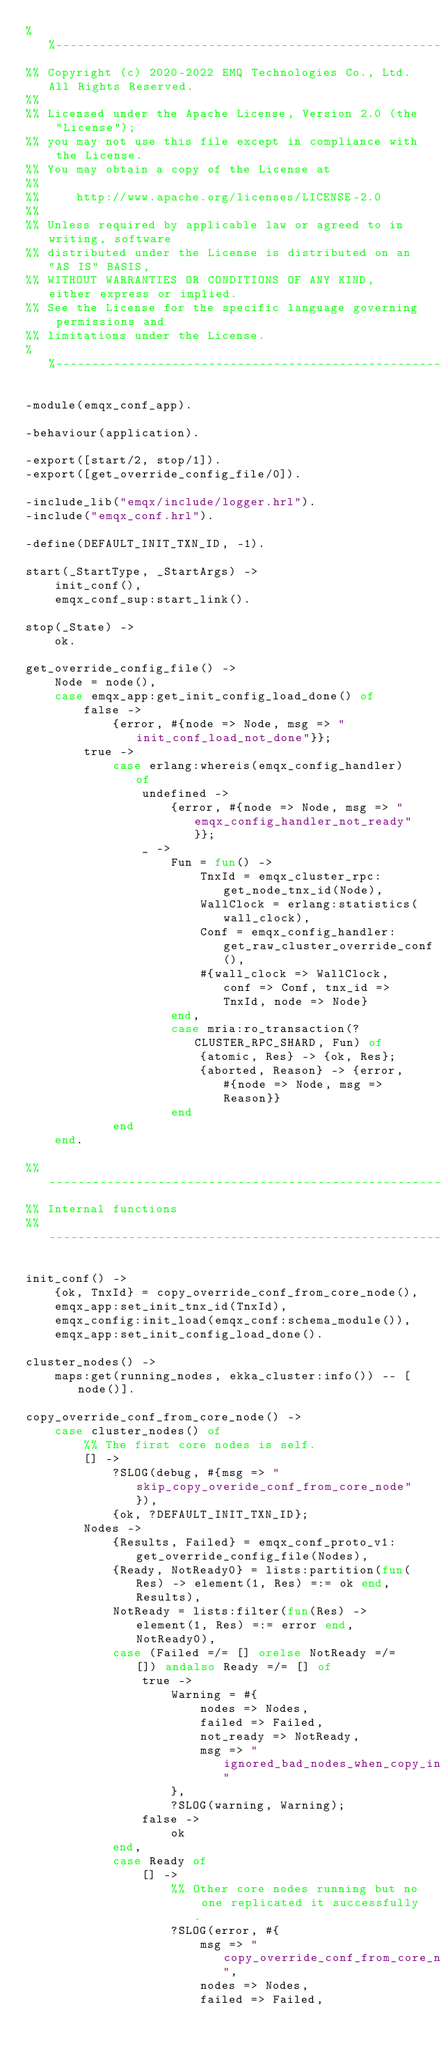<code> <loc_0><loc_0><loc_500><loc_500><_Erlang_>%%--------------------------------------------------------------------
%% Copyright (c) 2020-2022 EMQ Technologies Co., Ltd. All Rights Reserved.
%%
%% Licensed under the Apache License, Version 2.0 (the "License");
%% you may not use this file except in compliance with the License.
%% You may obtain a copy of the License at
%%
%%     http://www.apache.org/licenses/LICENSE-2.0
%%
%% Unless required by applicable law or agreed to in writing, software
%% distributed under the License is distributed on an "AS IS" BASIS,
%% WITHOUT WARRANTIES OR CONDITIONS OF ANY KIND, either express or implied.
%% See the License for the specific language governing permissions and
%% limitations under the License.
%%--------------------------------------------------------------------

-module(emqx_conf_app).

-behaviour(application).

-export([start/2, stop/1]).
-export([get_override_config_file/0]).

-include_lib("emqx/include/logger.hrl").
-include("emqx_conf.hrl").

-define(DEFAULT_INIT_TXN_ID, -1).

start(_StartType, _StartArgs) ->
    init_conf(),
    emqx_conf_sup:start_link().

stop(_State) ->
    ok.

get_override_config_file() ->
    Node = node(),
    case emqx_app:get_init_config_load_done() of
        false ->
            {error, #{node => Node, msg => "init_conf_load_not_done"}};
        true ->
            case erlang:whereis(emqx_config_handler) of
                undefined ->
                    {error, #{node => Node, msg => "emqx_config_handler_not_ready"}};
                _ ->
                    Fun = fun() ->
                        TnxId = emqx_cluster_rpc:get_node_tnx_id(Node),
                        WallClock = erlang:statistics(wall_clock),
                        Conf = emqx_config_handler:get_raw_cluster_override_conf(),
                        #{wall_clock => WallClock, conf => Conf, tnx_id => TnxId, node => Node}
                    end,
                    case mria:ro_transaction(?CLUSTER_RPC_SHARD, Fun) of
                        {atomic, Res} -> {ok, Res};
                        {aborted, Reason} -> {error, #{node => Node, msg => Reason}}
                    end
            end
    end.

%% ------------------------------------------------------------------------------
%% Internal functions
%% ------------------------------------------------------------------------------

init_conf() ->
    {ok, TnxId} = copy_override_conf_from_core_node(),
    emqx_app:set_init_tnx_id(TnxId),
    emqx_config:init_load(emqx_conf:schema_module()),
    emqx_app:set_init_config_load_done().

cluster_nodes() ->
    maps:get(running_nodes, ekka_cluster:info()) -- [node()].

copy_override_conf_from_core_node() ->
    case cluster_nodes() of
        %% The first core nodes is self.
        [] ->
            ?SLOG(debug, #{msg => "skip_copy_overide_conf_from_core_node"}),
            {ok, ?DEFAULT_INIT_TXN_ID};
        Nodes ->
            {Results, Failed} = emqx_conf_proto_v1:get_override_config_file(Nodes),
            {Ready, NotReady0} = lists:partition(fun(Res) -> element(1, Res) =:= ok end, Results),
            NotReady = lists:filter(fun(Res) -> element(1, Res) =:= error end, NotReady0),
            case (Failed =/= [] orelse NotReady =/= []) andalso Ready =/= [] of
                true ->
                    Warning = #{
                        nodes => Nodes,
                        failed => Failed,
                        not_ready => NotReady,
                        msg => "ignored_bad_nodes_when_copy_init_config"
                    },
                    ?SLOG(warning, Warning);
                false ->
                    ok
            end,
            case Ready of
                [] ->
                    %% Other core nodes running but no one replicated it successfully.
                    ?SLOG(error, #{
                        msg => "copy_override_conf_from_core_node_failed",
                        nodes => Nodes,
                        failed => Failed,</code> 